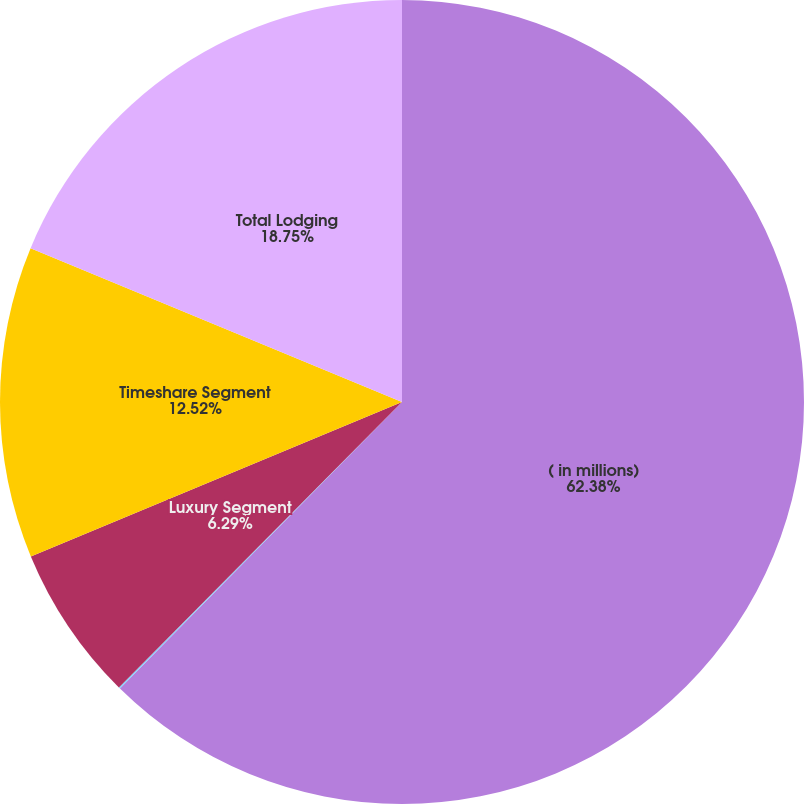Convert chart. <chart><loc_0><loc_0><loc_500><loc_500><pie_chart><fcel>( in millions)<fcel>North American Full-Service<fcel>Luxury Segment<fcel>Timeshare Segment<fcel>Total Lodging<nl><fcel>62.37%<fcel>0.06%<fcel>6.29%<fcel>12.52%<fcel>18.75%<nl></chart> 